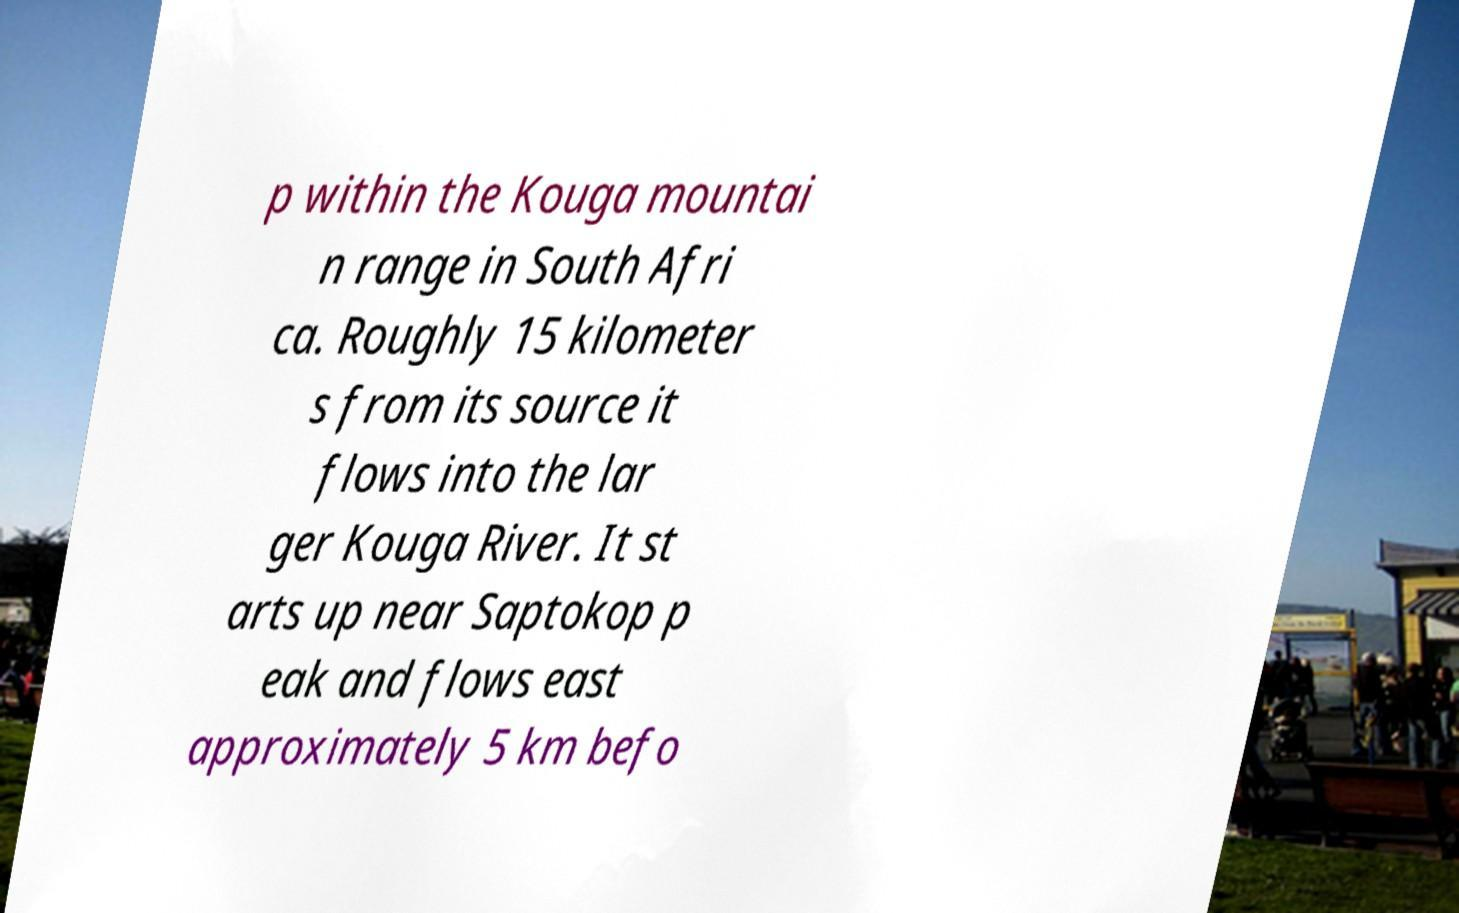Could you extract and type out the text from this image? p within the Kouga mountai n range in South Afri ca. Roughly 15 kilometer s from its source it flows into the lar ger Kouga River. It st arts up near Saptokop p eak and flows east approximately 5 km befo 